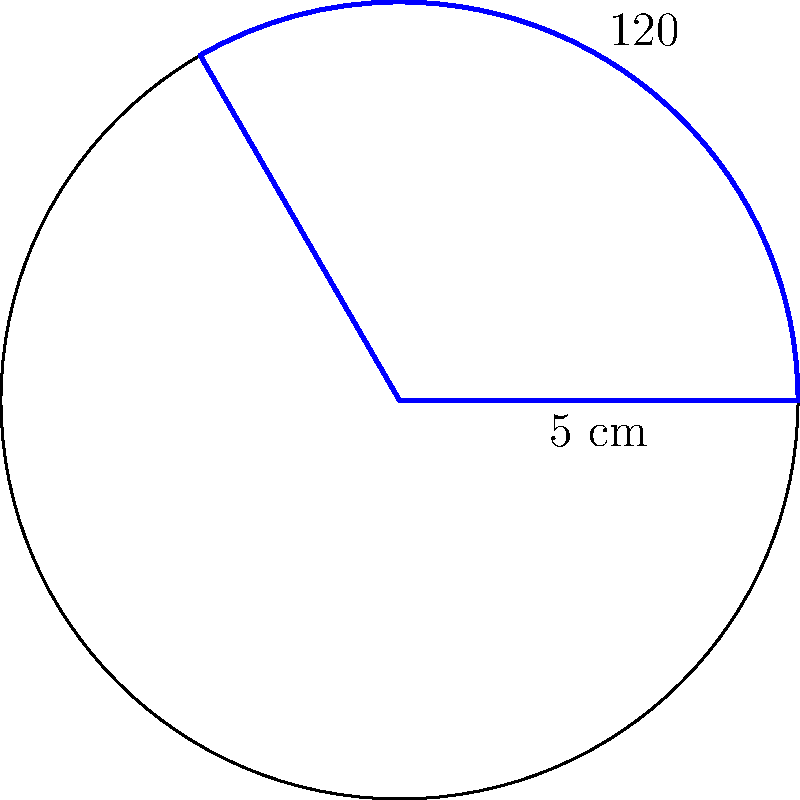A pie-shaped sector representing the signal strength of a Sprint network is shown above. The radius of the circle is 5 cm, and the central angle of the sector is 120°. Calculate the area of this sector, which represents the coverage area. Round your answer to two decimal places. How might this result affect your trust in Sprint's network coverage claims? To find the area of a sector, we use the formula:

$$A = \frac{\theta}{360°} \cdot \pi r^2$$

Where:
$A$ = Area of the sector
$\theta$ = Central angle in degrees
$r$ = Radius of the circle

Step 1: Identify the given values
$\theta = 120°$
$r = 5$ cm

Step 2: Substitute these values into the formula
$$A = \frac{120°}{360°} \cdot \pi (5 \text{ cm})^2$$

Step 3: Simplify
$$A = \frac{1}{3} \cdot \pi \cdot 25 \text{ cm}^2$$

Step 4: Calculate
$$A = \frac{25\pi}{3} \text{ cm}^2 \approx 26.18 \text{ cm}^2$$

Step 5: Round to two decimal places
$A \approx 26.18 \text{ cm}^2$

This result represents the theoretical coverage area based on the given angle and radius. As a skeptical Sprint user, you might question whether this simplified geometric representation accurately reflects real-world network coverage, which can be affected by various factors such as terrain, buildings, and atmospheric conditions.
Answer: 26.18 cm² 